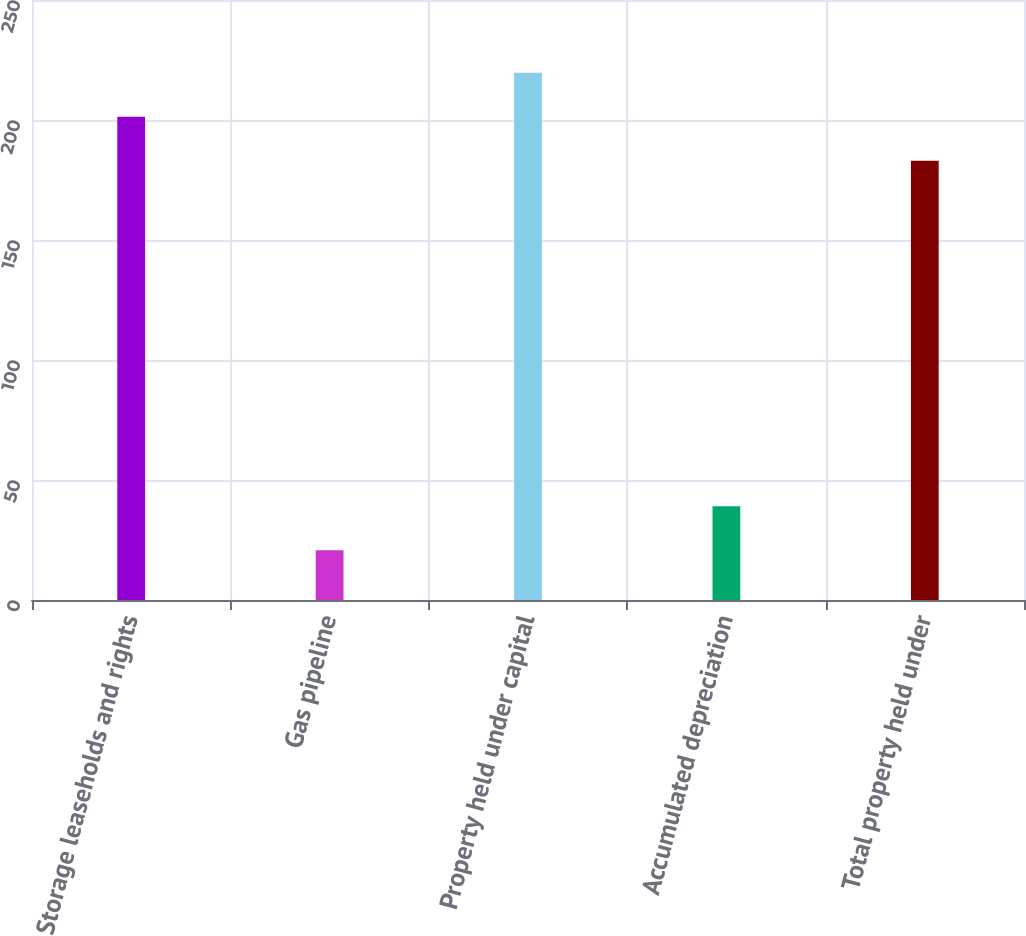<chart> <loc_0><loc_0><loc_500><loc_500><bar_chart><fcel>Storage leaseholds and rights<fcel>Gas pipeline<fcel>Property held under capital<fcel>Accumulated depreciation<fcel>Total property held under<nl><fcel>201.36<fcel>20.7<fcel>219.72<fcel>39.06<fcel>183<nl></chart> 